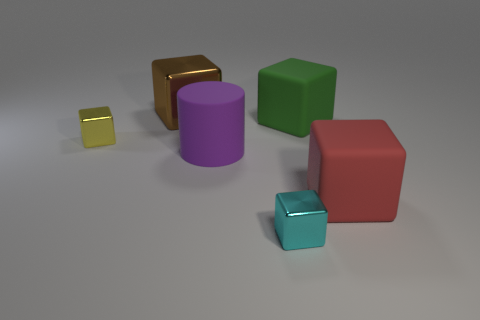Which objects in the image appear to have a texture? The small yellow cube and the large golden cuboid seem to have a distinct metallic texture compared to the other objects. 